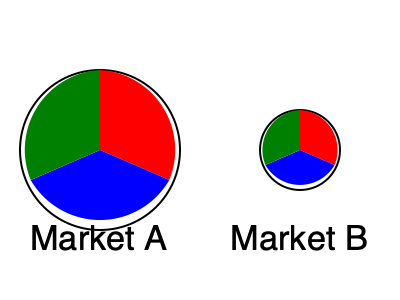Two pie charts represent the market share of your steakhouse chain in different cities. The larger pie chart (Market A) has a radius twice that of the smaller pie chart (Market B). If the red slice in Market A represents 30% of the total market share, what percentage does the red slice in Market B represent? To solve this problem, we need to follow these steps:

1. Understand the relationship between the pie charts:
   - Market A's radius is twice that of Market B
   - The area of a circle is proportional to the square of its radius

2. Calculate the relative sizes of the markets:
   - Area ratio = $(\frac{r_A}{r_B})^2 = 2^2 = 4$
   - Market A is 4 times larger than Market B

3. Analyze the red slice in Market A:
   - It represents 30% of Market A

4. Calculate the equivalent market share in Market B:
   - Market B's total size = $\frac{1}{4}$ of Market A
   - Red slice in Market A = 30% of Market A
   - Equivalent share in Market B = $30\% \times 4 = 120\%$

5. Interpret the result:
   - Since 120% is greater than the total size of Market B (100%), the red slice must occupy the entire pie chart of Market B and even extend beyond it.

6. Conclude:
   - The red slice in Market B represents 100% of the market share in that city.
Answer: 100% 